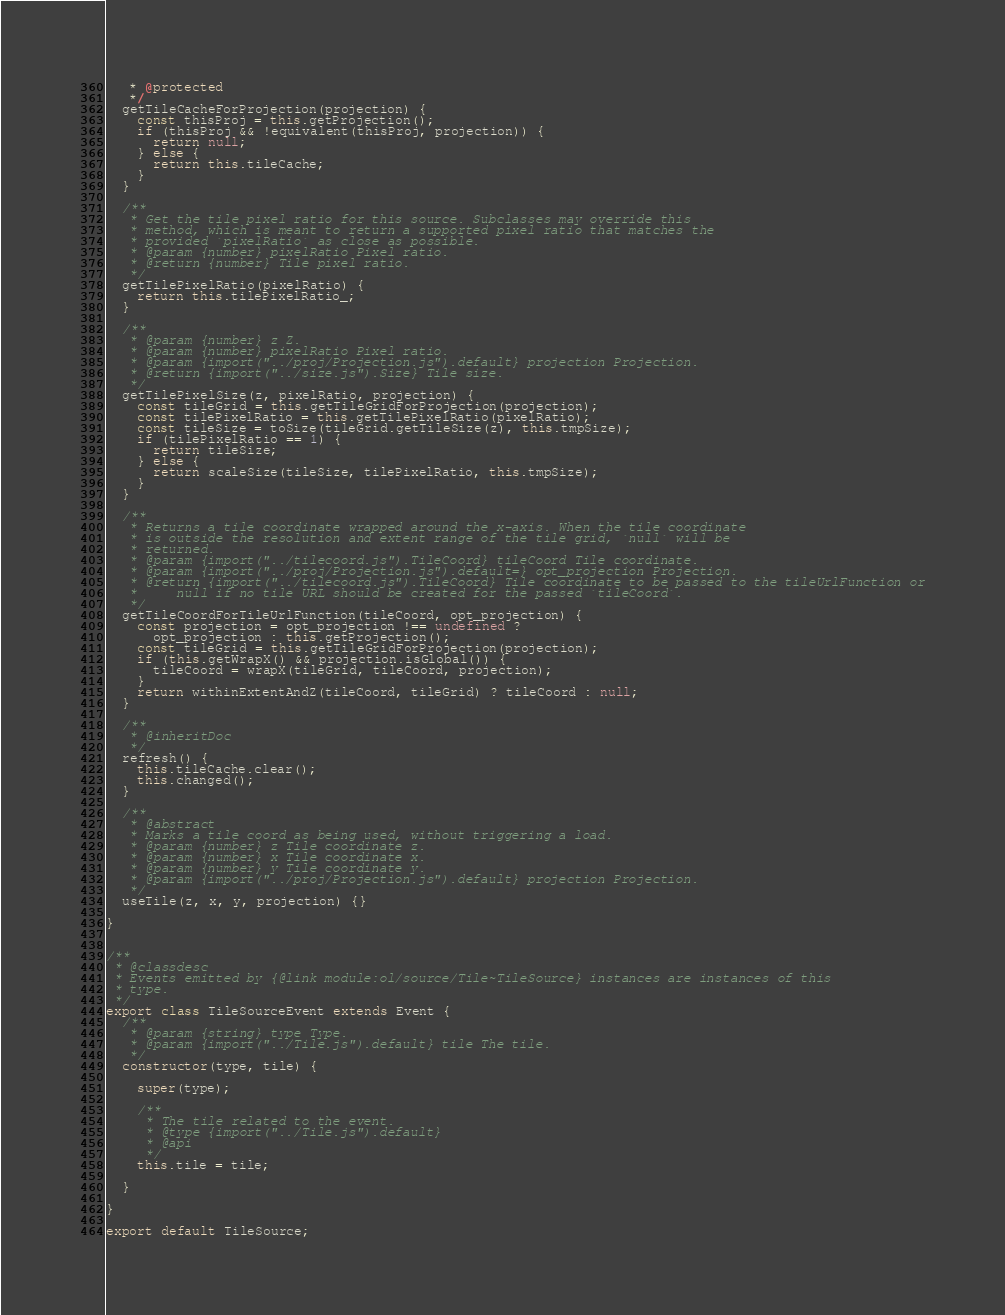<code> <loc_0><loc_0><loc_500><loc_500><_JavaScript_>   * @protected
   */
  getTileCacheForProjection(projection) {
    const thisProj = this.getProjection();
    if (thisProj && !equivalent(thisProj, projection)) {
      return null;
    } else {
      return this.tileCache;
    }
  }

  /**
   * Get the tile pixel ratio for this source. Subclasses may override this
   * method, which is meant to return a supported pixel ratio that matches the
   * provided `pixelRatio` as close as possible.
   * @param {number} pixelRatio Pixel ratio.
   * @return {number} Tile pixel ratio.
   */
  getTilePixelRatio(pixelRatio) {
    return this.tilePixelRatio_;
  }

  /**
   * @param {number} z Z.
   * @param {number} pixelRatio Pixel ratio.
   * @param {import("../proj/Projection.js").default} projection Projection.
   * @return {import("../size.js").Size} Tile size.
   */
  getTilePixelSize(z, pixelRatio, projection) {
    const tileGrid = this.getTileGridForProjection(projection);
    const tilePixelRatio = this.getTilePixelRatio(pixelRatio);
    const tileSize = toSize(tileGrid.getTileSize(z), this.tmpSize);
    if (tilePixelRatio == 1) {
      return tileSize;
    } else {
      return scaleSize(tileSize, tilePixelRatio, this.tmpSize);
    }
  }

  /**
   * Returns a tile coordinate wrapped around the x-axis. When the tile coordinate
   * is outside the resolution and extent range of the tile grid, `null` will be
   * returned.
   * @param {import("../tilecoord.js").TileCoord} tileCoord Tile coordinate.
   * @param {import("../proj/Projection.js").default=} opt_projection Projection.
   * @return {import("../tilecoord.js").TileCoord} Tile coordinate to be passed to the tileUrlFunction or
   *     null if no tile URL should be created for the passed `tileCoord`.
   */
  getTileCoordForTileUrlFunction(tileCoord, opt_projection) {
    const projection = opt_projection !== undefined ?
      opt_projection : this.getProjection();
    const tileGrid = this.getTileGridForProjection(projection);
    if (this.getWrapX() && projection.isGlobal()) {
      tileCoord = wrapX(tileGrid, tileCoord, projection);
    }
    return withinExtentAndZ(tileCoord, tileGrid) ? tileCoord : null;
  }

  /**
   * @inheritDoc
   */
  refresh() {
    this.tileCache.clear();
    this.changed();
  }

  /**
   * @abstract
   * Marks a tile coord as being used, without triggering a load.
   * @param {number} z Tile coordinate z.
   * @param {number} x Tile coordinate x.
   * @param {number} y Tile coordinate y.
   * @param {import("../proj/Projection.js").default} projection Projection.
   */
  useTile(z, x, y, projection) {}

}


/**
 * @classdesc
 * Events emitted by {@link module:ol/source/Tile~TileSource} instances are instances of this
 * type.
 */
export class TileSourceEvent extends Event {
  /**
   * @param {string} type Type.
   * @param {import("../Tile.js").default} tile The tile.
   */
  constructor(type, tile) {

    super(type);

    /**
     * The tile related to the event.
     * @type {import("../Tile.js").default}
     * @api
     */
    this.tile = tile;

  }

}

export default TileSource;
</code> 